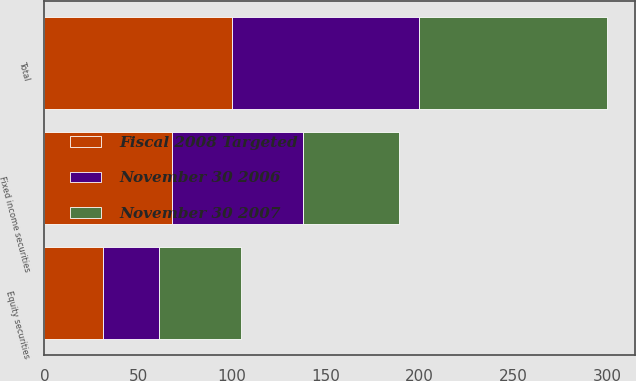Convert chart to OTSL. <chart><loc_0><loc_0><loc_500><loc_500><stacked_bar_chart><ecel><fcel>Equity securities<fcel>Fixed income securities<fcel>Total<nl><fcel>November 30 2006<fcel>30<fcel>70<fcel>100<nl><fcel>Fiscal 2008 Targeted<fcel>31<fcel>68<fcel>100<nl><fcel>November 30 2007<fcel>44<fcel>51<fcel>100<nl></chart> 